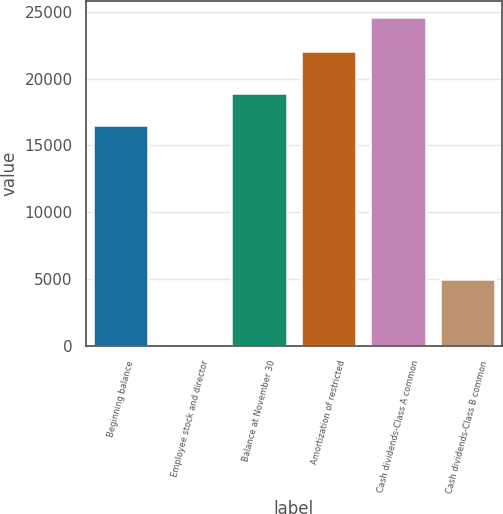<chart> <loc_0><loc_0><loc_500><loc_500><bar_chart><fcel>Beginning balance<fcel>Employee stock and director<fcel>Balance at November 30<fcel>Amortization of restricted<fcel>Cash dividends-Class A common<fcel>Cash dividends-Class B common<nl><fcel>16515<fcel>186<fcel>18953.4<fcel>22090<fcel>24570<fcel>5007<nl></chart> 